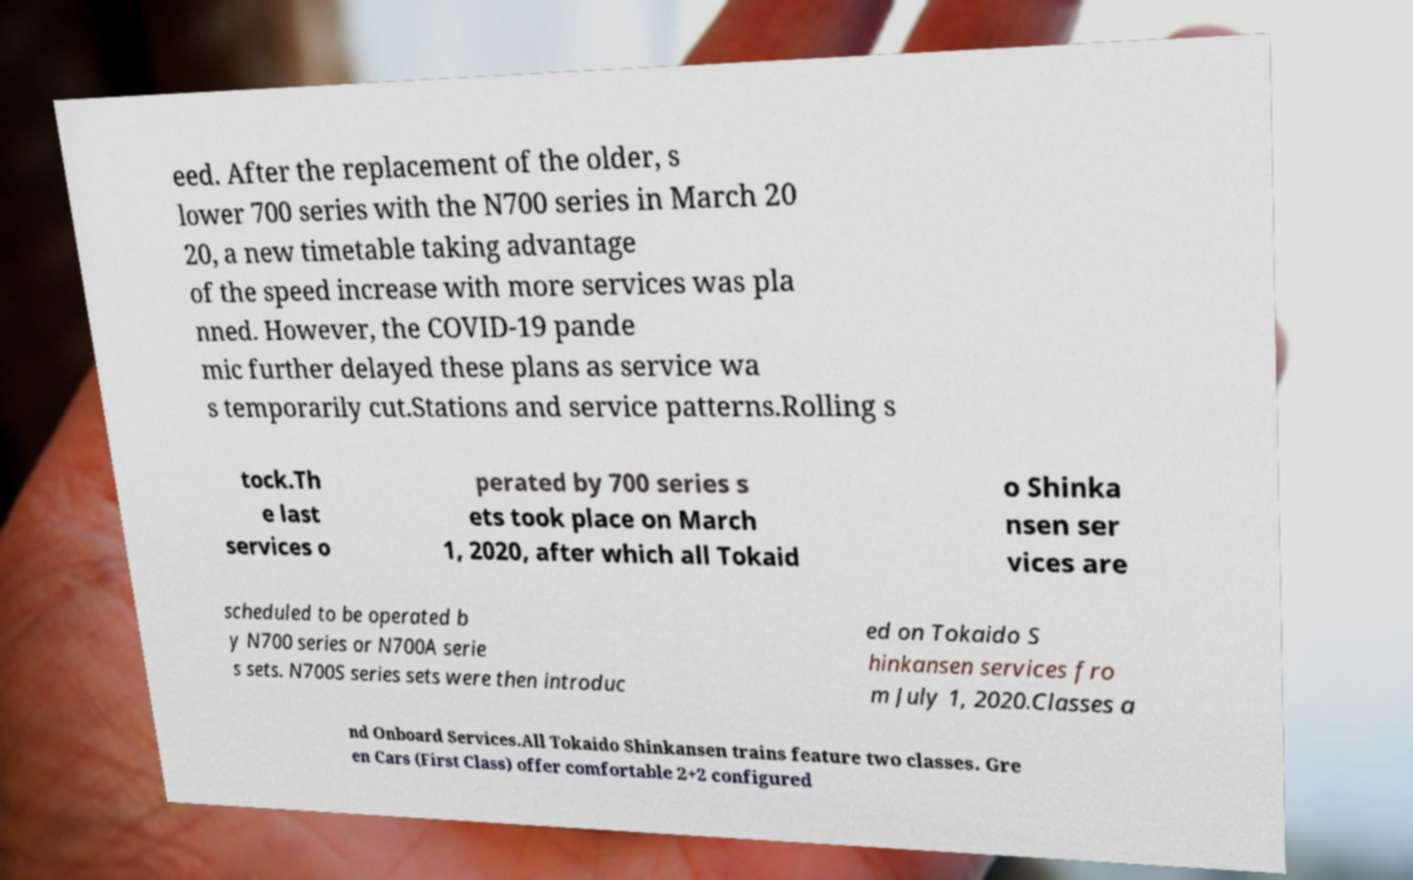Can you read and provide the text displayed in the image?This photo seems to have some interesting text. Can you extract and type it out for me? eed. After the replacement of the older, s lower 700 series with the N700 series in March 20 20, a new timetable taking advantage of the speed increase with more services was pla nned. However, the COVID-19 pande mic further delayed these plans as service wa s temporarily cut.Stations and service patterns.Rolling s tock.Th e last services o perated by 700 series s ets took place on March 1, 2020, after which all Tokaid o Shinka nsen ser vices are scheduled to be operated b y N700 series or N700A serie s sets. N700S series sets were then introduc ed on Tokaido S hinkansen services fro m July 1, 2020.Classes a nd Onboard Services.All Tokaido Shinkansen trains feature two classes. Gre en Cars (First Class) offer comfortable 2+2 configured 